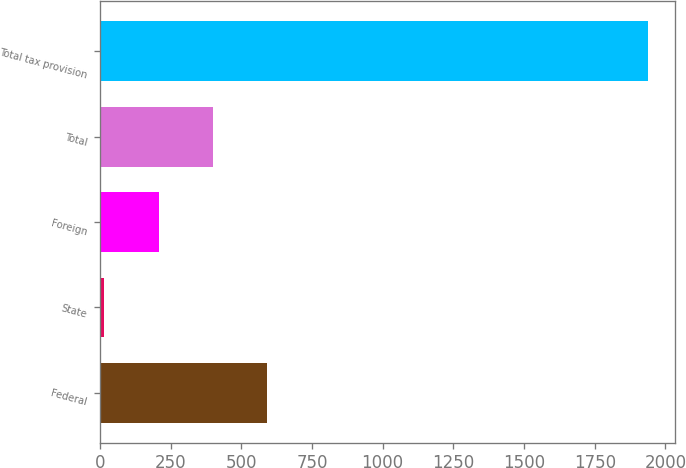Convert chart. <chart><loc_0><loc_0><loc_500><loc_500><bar_chart><fcel>Federal<fcel>State<fcel>Foreign<fcel>Total<fcel>Total tax provision<nl><fcel>592.6<fcel>16<fcel>208.2<fcel>400.4<fcel>1938<nl></chart> 